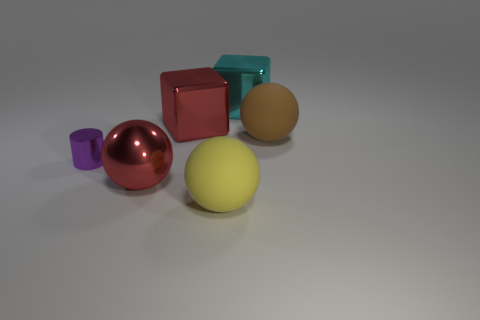What number of rubber things are large brown things or large cyan cubes?
Your response must be concise. 1. Are there the same number of blocks that are in front of the tiny purple metal object and small purple cylinders?
Give a very brief answer. No. There is a large rubber thing in front of the purple metallic thing; is its color the same as the metallic ball?
Your answer should be very brief. No. The thing that is both behind the large brown matte thing and on the left side of the cyan thing is made of what material?
Your response must be concise. Metal. Is there a large yellow matte ball that is on the left side of the matte object right of the yellow thing?
Your response must be concise. Yes. Is the big yellow thing made of the same material as the big brown object?
Your answer should be very brief. Yes. There is a large object that is left of the cyan metallic cube and to the right of the big red cube; what shape is it?
Your answer should be very brief. Sphere. There is a rubber ball on the right side of the large yellow object that is right of the red cube; how big is it?
Make the answer very short. Large. How many big brown rubber objects have the same shape as the cyan metallic object?
Provide a succinct answer. 0. Does the small metallic thing have the same color as the big metallic ball?
Keep it short and to the point. No. 